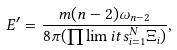Convert formula to latex. <formula><loc_0><loc_0><loc_500><loc_500>E ^ { \prime } = \frac { m ( n - 2 ) \omega _ { n - 2 } } { 8 \pi ( \prod \lim i t s _ { i = 1 } ^ { N } \Xi _ { i } ) } ,</formula> 